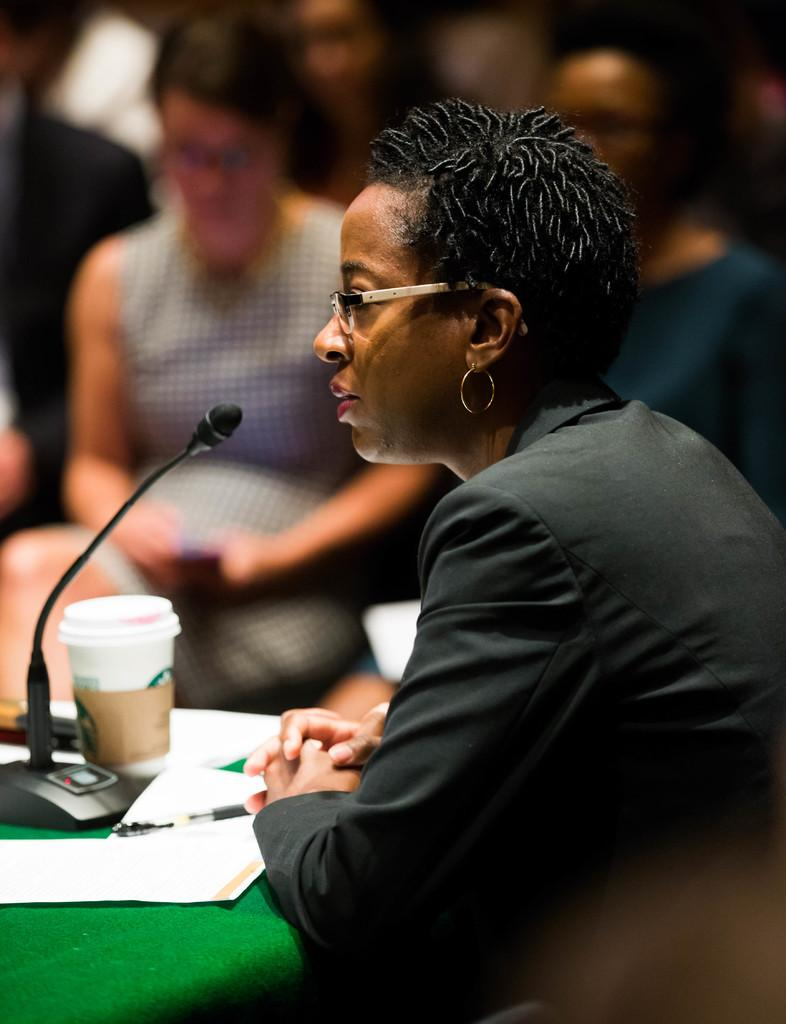What are the persons in the image doing? The persons in the image are sitting. What is in front of the persons? There is a table in front of the persons. What objects can be seen on the table? A microphone, a cup, a paper, and a pen are present on the table. What type of cookware can be seen on the stage in the image? There is no cookware or stage present in the image. Can you tell me how many airplanes are visible in the image? There are no airplanes visible in the image. 